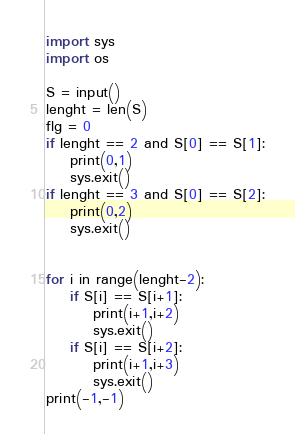Convert code to text. <code><loc_0><loc_0><loc_500><loc_500><_Python_>import sys
import os

S = input()
lenght = len(S)
flg = 0
if lenght == 2 and S[0] == S[1]:
    print(0,1)
    sys.exit()
if lenght == 3 and S[0] == S[2]:
    print(0,2)
    sys.exit()


for i in range(lenght-2):
    if S[i] == S[i+1]:
        print(i+1,i+2)
        sys.exit()
    if S[i] == S[i+2]:
        print(i+1,i+3)
        sys.exit()
print(-1,-1)
</code> 